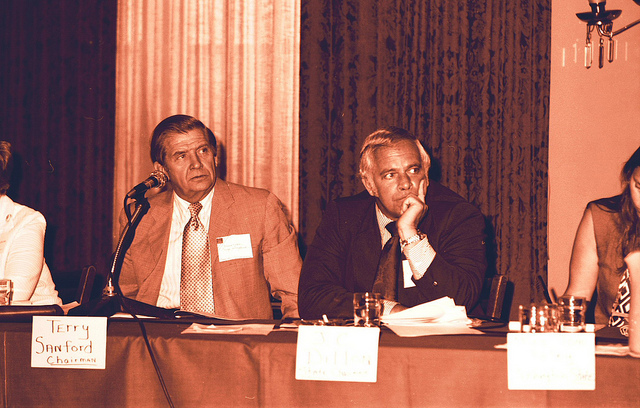<image>What are the men looking at? It is unknown what the men are looking at. They could be looking at a speaker, a presentation, or people. What are the men looking at? I am not sure what the men are looking at. It can be a presentation, a speaker, or someone speaking. 